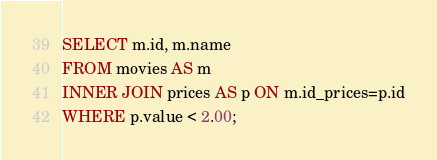<code> <loc_0><loc_0><loc_500><loc_500><_SQL_>SELECT m.id, m.name
FROM movies AS m
INNER JOIN prices AS p ON m.id_prices=p.id
WHERE p.value < 2.00;
</code> 